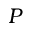<formula> <loc_0><loc_0><loc_500><loc_500>P</formula> 